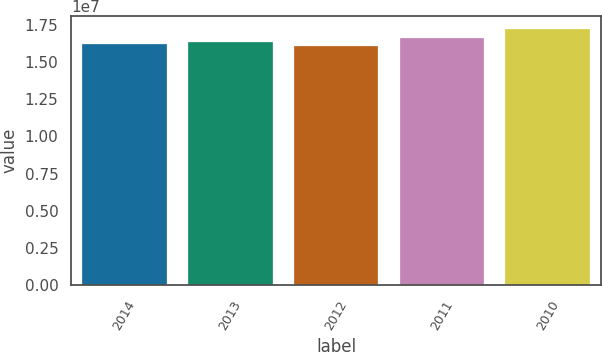<chart> <loc_0><loc_0><loc_500><loc_500><bar_chart><fcel>2014<fcel>2013<fcel>2012<fcel>2011<fcel>2010<nl><fcel>1.62173e+07<fcel>1.63286e+07<fcel>1.6106e+07<fcel>1.6623e+07<fcel>1.7219e+07<nl></chart> 